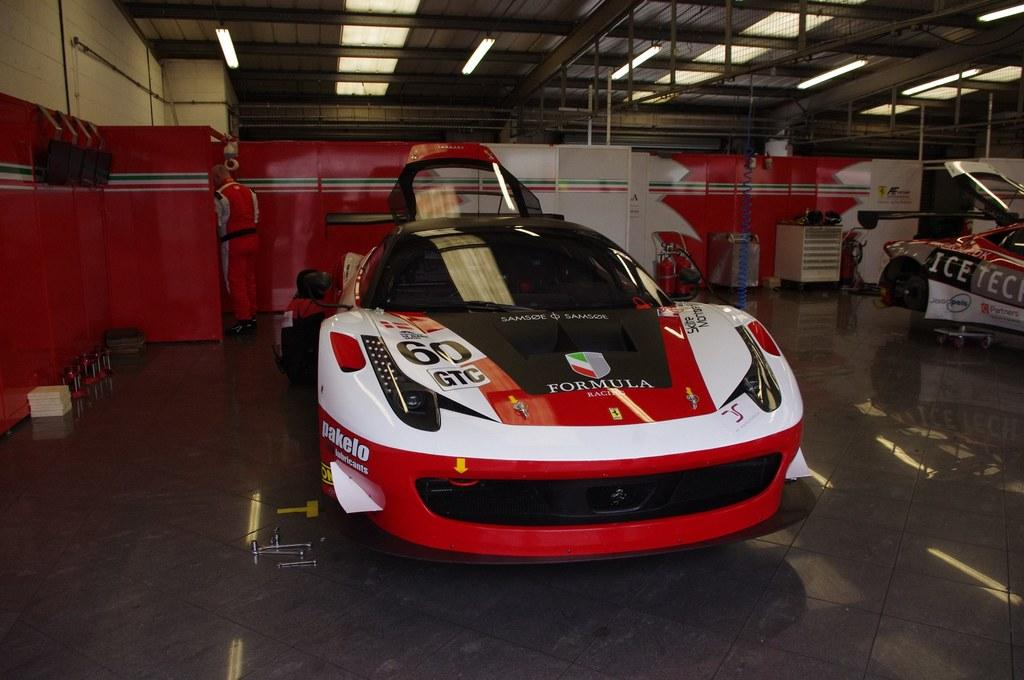What type of vehicles can be seen in the image? There are cars in the image. How many people are present in the image? There are two persons in the image. What can be seen in the background of the image? There are lights, metal rods, and machines visible in the background of the image. What type of lettuce is being distributed by the ball in the image? There is no ball or lettuce present in the image. 